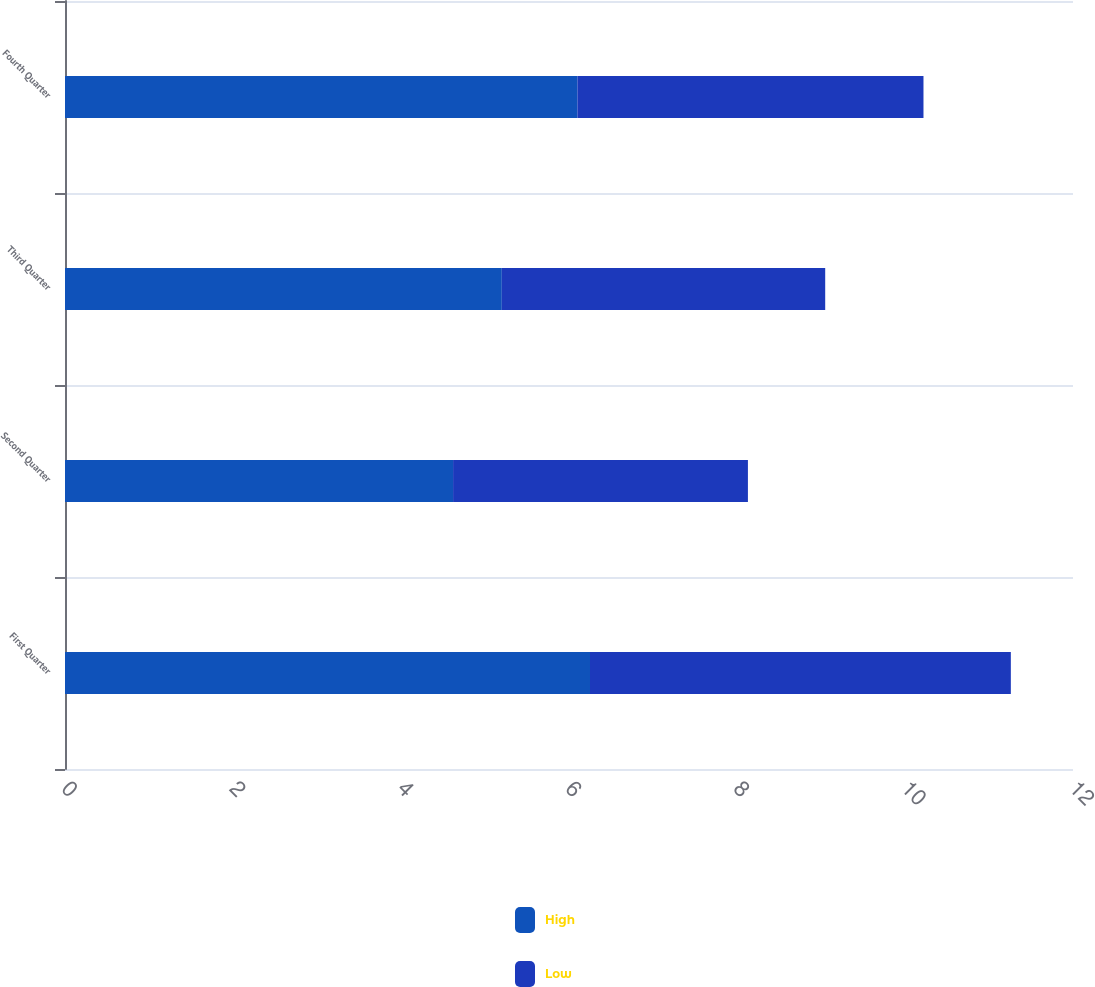<chart> <loc_0><loc_0><loc_500><loc_500><stacked_bar_chart><ecel><fcel>First Quarter<fcel>Second Quarter<fcel>Third Quarter<fcel>Fourth Quarter<nl><fcel>High<fcel>6.25<fcel>4.62<fcel>5.2<fcel>6.1<nl><fcel>Low<fcel>5.01<fcel>3.51<fcel>3.85<fcel>4.12<nl></chart> 